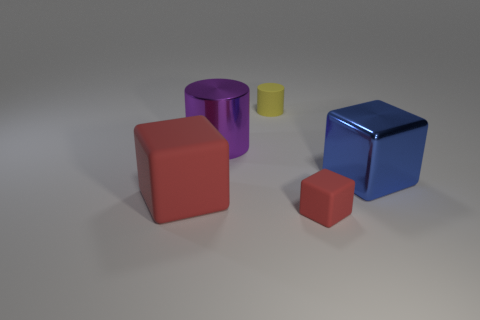Add 4 purple cylinders. How many objects exist? 9 Subtract all cylinders. How many objects are left? 3 Subtract all purple metallic cylinders. Subtract all purple shiny cylinders. How many objects are left? 3 Add 5 yellow matte cylinders. How many yellow matte cylinders are left? 6 Add 1 matte cylinders. How many matte cylinders exist? 2 Subtract 1 blue cubes. How many objects are left? 4 